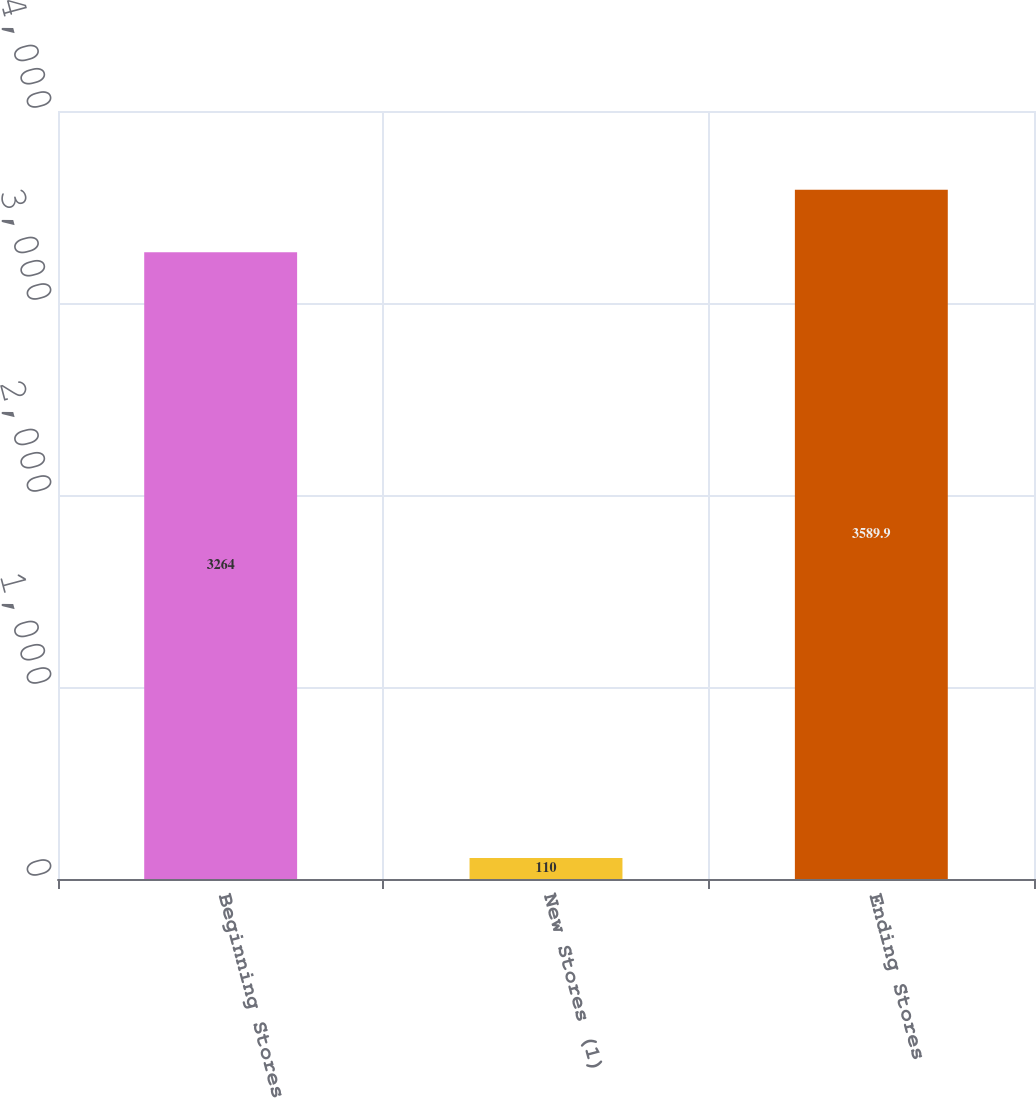Convert chart. <chart><loc_0><loc_0><loc_500><loc_500><bar_chart><fcel>Beginning Stores<fcel>New Stores (1)<fcel>Ending Stores<nl><fcel>3264<fcel>110<fcel>3589.9<nl></chart> 